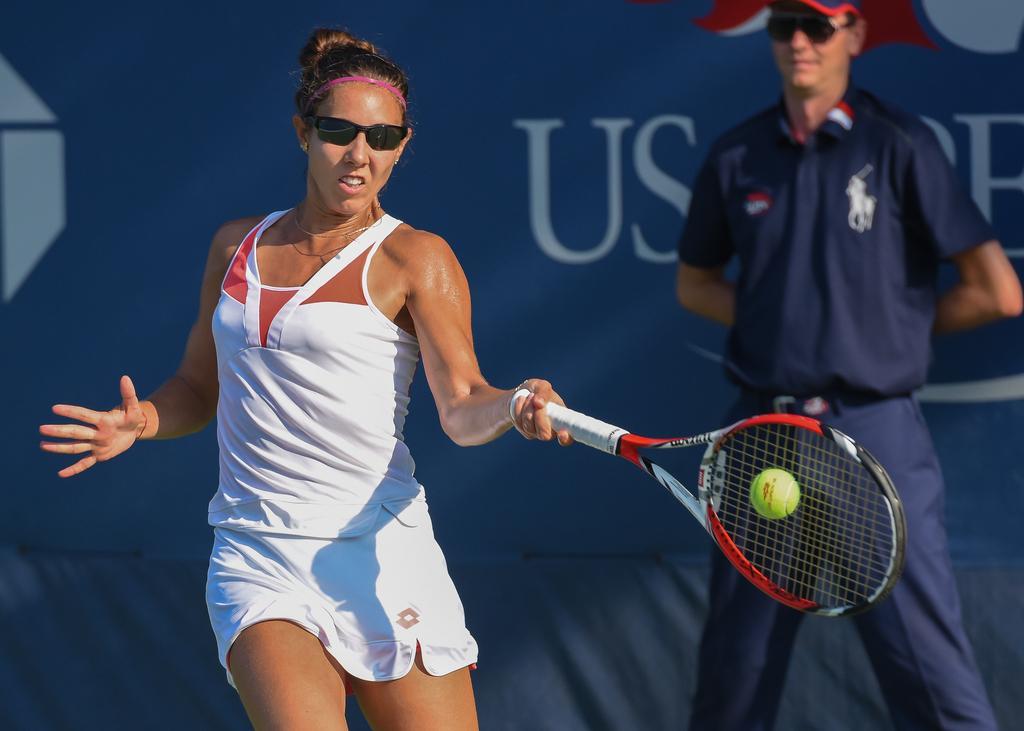Can you describe this image briefly? In this image we can see there is a person playing tennis and there is another person standing. And at the back there is a banner. 